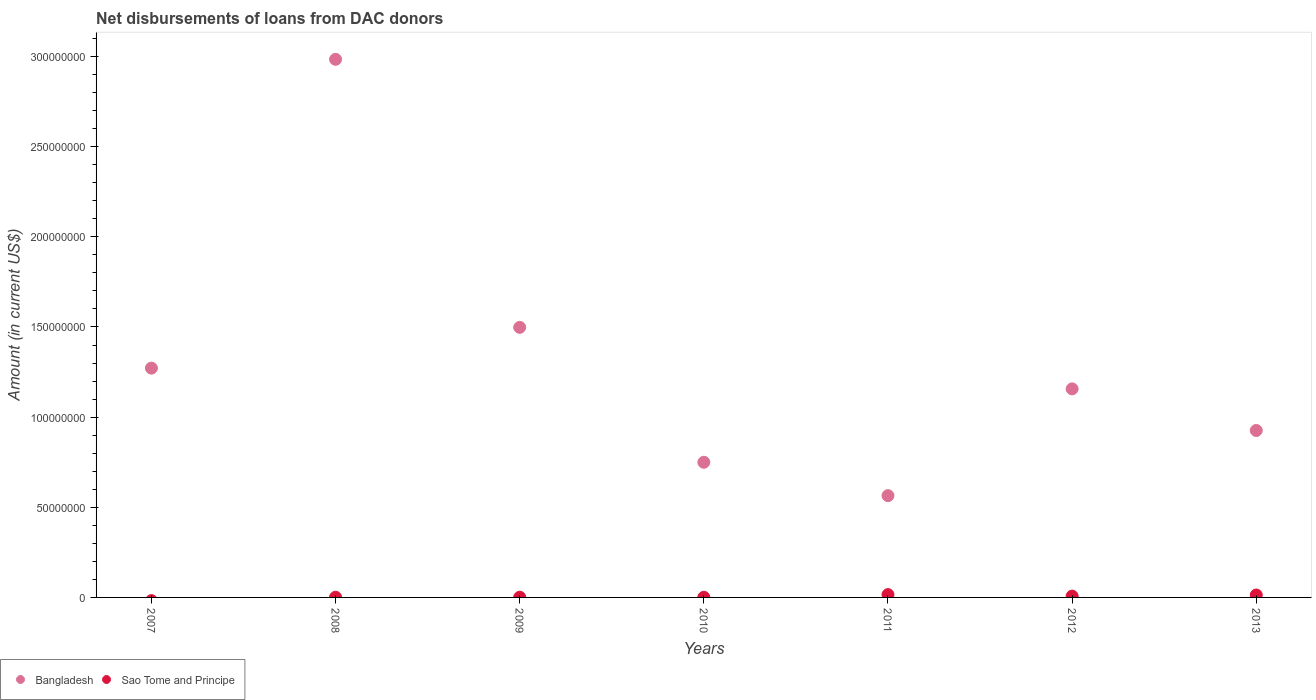Is the number of dotlines equal to the number of legend labels?
Your response must be concise. No. What is the amount of loans disbursed in Bangladesh in 2011?
Your answer should be very brief. 5.64e+07. Across all years, what is the maximum amount of loans disbursed in Sao Tome and Principe?
Provide a short and direct response. 1.56e+06. Across all years, what is the minimum amount of loans disbursed in Bangladesh?
Your answer should be compact. 5.64e+07. In which year was the amount of loans disbursed in Sao Tome and Principe maximum?
Ensure brevity in your answer.  2011. What is the total amount of loans disbursed in Sao Tome and Principe in the graph?
Provide a succinct answer. 3.98e+06. What is the difference between the amount of loans disbursed in Sao Tome and Principe in 2010 and that in 2011?
Your answer should be compact. -1.47e+06. What is the difference between the amount of loans disbursed in Sao Tome and Principe in 2011 and the amount of loans disbursed in Bangladesh in 2013?
Your answer should be very brief. -9.10e+07. What is the average amount of loans disbursed in Bangladesh per year?
Your answer should be very brief. 1.31e+08. In the year 2008, what is the difference between the amount of loans disbursed in Bangladesh and amount of loans disbursed in Sao Tome and Principe?
Provide a short and direct response. 2.98e+08. In how many years, is the amount of loans disbursed in Bangladesh greater than 120000000 US$?
Your response must be concise. 3. What is the ratio of the amount of loans disbursed in Sao Tome and Principe in 2008 to that in 2010?
Your answer should be very brief. 1.27. Is the difference between the amount of loans disbursed in Bangladesh in 2009 and 2013 greater than the difference between the amount of loans disbursed in Sao Tome and Principe in 2009 and 2013?
Keep it short and to the point. Yes. What is the difference between the highest and the second highest amount of loans disbursed in Sao Tome and Principe?
Provide a succinct answer. 2.13e+05. What is the difference between the highest and the lowest amount of loans disbursed in Bangladesh?
Your answer should be compact. 2.42e+08. How many dotlines are there?
Give a very brief answer. 2. How many years are there in the graph?
Provide a succinct answer. 7. Does the graph contain any zero values?
Your answer should be compact. Yes. Does the graph contain grids?
Your response must be concise. No. How are the legend labels stacked?
Give a very brief answer. Horizontal. What is the title of the graph?
Your answer should be very brief. Net disbursements of loans from DAC donors. What is the Amount (in current US$) of Bangladesh in 2007?
Your answer should be compact. 1.27e+08. What is the Amount (in current US$) of Bangladesh in 2008?
Offer a very short reply. 2.98e+08. What is the Amount (in current US$) of Sao Tome and Principe in 2008?
Your response must be concise. 1.18e+05. What is the Amount (in current US$) in Bangladesh in 2009?
Make the answer very short. 1.50e+08. What is the Amount (in current US$) of Sao Tome and Principe in 2009?
Your answer should be compact. 1.20e+05. What is the Amount (in current US$) of Bangladesh in 2010?
Provide a succinct answer. 7.50e+07. What is the Amount (in current US$) of Sao Tome and Principe in 2010?
Your response must be concise. 9.30e+04. What is the Amount (in current US$) in Bangladesh in 2011?
Your answer should be very brief. 5.64e+07. What is the Amount (in current US$) of Sao Tome and Principe in 2011?
Ensure brevity in your answer.  1.56e+06. What is the Amount (in current US$) of Bangladesh in 2012?
Your response must be concise. 1.16e+08. What is the Amount (in current US$) of Sao Tome and Principe in 2012?
Offer a terse response. 7.36e+05. What is the Amount (in current US$) of Bangladesh in 2013?
Ensure brevity in your answer.  9.26e+07. What is the Amount (in current US$) of Sao Tome and Principe in 2013?
Keep it short and to the point. 1.35e+06. Across all years, what is the maximum Amount (in current US$) of Bangladesh?
Provide a succinct answer. 2.98e+08. Across all years, what is the maximum Amount (in current US$) of Sao Tome and Principe?
Offer a terse response. 1.56e+06. Across all years, what is the minimum Amount (in current US$) of Bangladesh?
Your response must be concise. 5.64e+07. Across all years, what is the minimum Amount (in current US$) in Sao Tome and Principe?
Provide a succinct answer. 0. What is the total Amount (in current US$) of Bangladesh in the graph?
Give a very brief answer. 9.15e+08. What is the total Amount (in current US$) in Sao Tome and Principe in the graph?
Provide a succinct answer. 3.98e+06. What is the difference between the Amount (in current US$) in Bangladesh in 2007 and that in 2008?
Your response must be concise. -1.71e+08. What is the difference between the Amount (in current US$) in Bangladesh in 2007 and that in 2009?
Provide a succinct answer. -2.26e+07. What is the difference between the Amount (in current US$) of Bangladesh in 2007 and that in 2010?
Your response must be concise. 5.22e+07. What is the difference between the Amount (in current US$) of Bangladesh in 2007 and that in 2011?
Make the answer very short. 7.07e+07. What is the difference between the Amount (in current US$) in Bangladesh in 2007 and that in 2012?
Offer a very short reply. 1.15e+07. What is the difference between the Amount (in current US$) in Bangladesh in 2007 and that in 2013?
Provide a short and direct response. 3.46e+07. What is the difference between the Amount (in current US$) in Bangladesh in 2008 and that in 2009?
Provide a succinct answer. 1.49e+08. What is the difference between the Amount (in current US$) of Sao Tome and Principe in 2008 and that in 2009?
Your answer should be compact. -2000. What is the difference between the Amount (in current US$) of Bangladesh in 2008 and that in 2010?
Keep it short and to the point. 2.24e+08. What is the difference between the Amount (in current US$) in Sao Tome and Principe in 2008 and that in 2010?
Offer a very short reply. 2.50e+04. What is the difference between the Amount (in current US$) of Bangladesh in 2008 and that in 2011?
Your answer should be very brief. 2.42e+08. What is the difference between the Amount (in current US$) of Sao Tome and Principe in 2008 and that in 2011?
Your answer should be compact. -1.44e+06. What is the difference between the Amount (in current US$) in Bangladesh in 2008 and that in 2012?
Provide a succinct answer. 1.83e+08. What is the difference between the Amount (in current US$) in Sao Tome and Principe in 2008 and that in 2012?
Make the answer very short. -6.18e+05. What is the difference between the Amount (in current US$) in Bangladesh in 2008 and that in 2013?
Provide a succinct answer. 2.06e+08. What is the difference between the Amount (in current US$) of Sao Tome and Principe in 2008 and that in 2013?
Provide a short and direct response. -1.23e+06. What is the difference between the Amount (in current US$) of Bangladesh in 2009 and that in 2010?
Offer a terse response. 7.48e+07. What is the difference between the Amount (in current US$) in Sao Tome and Principe in 2009 and that in 2010?
Provide a short and direct response. 2.70e+04. What is the difference between the Amount (in current US$) of Bangladesh in 2009 and that in 2011?
Ensure brevity in your answer.  9.33e+07. What is the difference between the Amount (in current US$) in Sao Tome and Principe in 2009 and that in 2011?
Your answer should be very brief. -1.44e+06. What is the difference between the Amount (in current US$) in Bangladesh in 2009 and that in 2012?
Keep it short and to the point. 3.41e+07. What is the difference between the Amount (in current US$) in Sao Tome and Principe in 2009 and that in 2012?
Your answer should be compact. -6.16e+05. What is the difference between the Amount (in current US$) of Bangladesh in 2009 and that in 2013?
Give a very brief answer. 5.72e+07. What is the difference between the Amount (in current US$) in Sao Tome and Principe in 2009 and that in 2013?
Offer a very short reply. -1.23e+06. What is the difference between the Amount (in current US$) in Bangladesh in 2010 and that in 2011?
Offer a terse response. 1.85e+07. What is the difference between the Amount (in current US$) of Sao Tome and Principe in 2010 and that in 2011?
Your answer should be very brief. -1.47e+06. What is the difference between the Amount (in current US$) in Bangladesh in 2010 and that in 2012?
Keep it short and to the point. -4.07e+07. What is the difference between the Amount (in current US$) of Sao Tome and Principe in 2010 and that in 2012?
Keep it short and to the point. -6.43e+05. What is the difference between the Amount (in current US$) of Bangladesh in 2010 and that in 2013?
Provide a succinct answer. -1.76e+07. What is the difference between the Amount (in current US$) of Sao Tome and Principe in 2010 and that in 2013?
Offer a terse response. -1.26e+06. What is the difference between the Amount (in current US$) in Bangladesh in 2011 and that in 2012?
Provide a short and direct response. -5.92e+07. What is the difference between the Amount (in current US$) of Sao Tome and Principe in 2011 and that in 2012?
Provide a short and direct response. 8.27e+05. What is the difference between the Amount (in current US$) in Bangladesh in 2011 and that in 2013?
Provide a succinct answer. -3.61e+07. What is the difference between the Amount (in current US$) in Sao Tome and Principe in 2011 and that in 2013?
Keep it short and to the point. 2.13e+05. What is the difference between the Amount (in current US$) of Bangladesh in 2012 and that in 2013?
Your answer should be compact. 2.31e+07. What is the difference between the Amount (in current US$) in Sao Tome and Principe in 2012 and that in 2013?
Make the answer very short. -6.14e+05. What is the difference between the Amount (in current US$) of Bangladesh in 2007 and the Amount (in current US$) of Sao Tome and Principe in 2008?
Keep it short and to the point. 1.27e+08. What is the difference between the Amount (in current US$) of Bangladesh in 2007 and the Amount (in current US$) of Sao Tome and Principe in 2009?
Offer a terse response. 1.27e+08. What is the difference between the Amount (in current US$) of Bangladesh in 2007 and the Amount (in current US$) of Sao Tome and Principe in 2010?
Provide a short and direct response. 1.27e+08. What is the difference between the Amount (in current US$) of Bangladesh in 2007 and the Amount (in current US$) of Sao Tome and Principe in 2011?
Ensure brevity in your answer.  1.26e+08. What is the difference between the Amount (in current US$) in Bangladesh in 2007 and the Amount (in current US$) in Sao Tome and Principe in 2012?
Offer a very short reply. 1.26e+08. What is the difference between the Amount (in current US$) in Bangladesh in 2007 and the Amount (in current US$) in Sao Tome and Principe in 2013?
Provide a succinct answer. 1.26e+08. What is the difference between the Amount (in current US$) of Bangladesh in 2008 and the Amount (in current US$) of Sao Tome and Principe in 2009?
Offer a terse response. 2.98e+08. What is the difference between the Amount (in current US$) of Bangladesh in 2008 and the Amount (in current US$) of Sao Tome and Principe in 2010?
Give a very brief answer. 2.98e+08. What is the difference between the Amount (in current US$) of Bangladesh in 2008 and the Amount (in current US$) of Sao Tome and Principe in 2011?
Make the answer very short. 2.97e+08. What is the difference between the Amount (in current US$) in Bangladesh in 2008 and the Amount (in current US$) in Sao Tome and Principe in 2012?
Offer a very short reply. 2.98e+08. What is the difference between the Amount (in current US$) in Bangladesh in 2008 and the Amount (in current US$) in Sao Tome and Principe in 2013?
Your answer should be compact. 2.97e+08. What is the difference between the Amount (in current US$) of Bangladesh in 2009 and the Amount (in current US$) of Sao Tome and Principe in 2010?
Ensure brevity in your answer.  1.50e+08. What is the difference between the Amount (in current US$) of Bangladesh in 2009 and the Amount (in current US$) of Sao Tome and Principe in 2011?
Your response must be concise. 1.48e+08. What is the difference between the Amount (in current US$) in Bangladesh in 2009 and the Amount (in current US$) in Sao Tome and Principe in 2012?
Offer a terse response. 1.49e+08. What is the difference between the Amount (in current US$) of Bangladesh in 2009 and the Amount (in current US$) of Sao Tome and Principe in 2013?
Give a very brief answer. 1.48e+08. What is the difference between the Amount (in current US$) of Bangladesh in 2010 and the Amount (in current US$) of Sao Tome and Principe in 2011?
Your response must be concise. 7.34e+07. What is the difference between the Amount (in current US$) of Bangladesh in 2010 and the Amount (in current US$) of Sao Tome and Principe in 2012?
Provide a succinct answer. 7.42e+07. What is the difference between the Amount (in current US$) of Bangladesh in 2010 and the Amount (in current US$) of Sao Tome and Principe in 2013?
Your response must be concise. 7.36e+07. What is the difference between the Amount (in current US$) in Bangladesh in 2011 and the Amount (in current US$) in Sao Tome and Principe in 2012?
Give a very brief answer. 5.57e+07. What is the difference between the Amount (in current US$) in Bangladesh in 2011 and the Amount (in current US$) in Sao Tome and Principe in 2013?
Your answer should be very brief. 5.51e+07. What is the difference between the Amount (in current US$) in Bangladesh in 2012 and the Amount (in current US$) in Sao Tome and Principe in 2013?
Ensure brevity in your answer.  1.14e+08. What is the average Amount (in current US$) of Bangladesh per year?
Ensure brevity in your answer.  1.31e+08. What is the average Amount (in current US$) in Sao Tome and Principe per year?
Ensure brevity in your answer.  5.69e+05. In the year 2008, what is the difference between the Amount (in current US$) of Bangladesh and Amount (in current US$) of Sao Tome and Principe?
Offer a terse response. 2.98e+08. In the year 2009, what is the difference between the Amount (in current US$) in Bangladesh and Amount (in current US$) in Sao Tome and Principe?
Keep it short and to the point. 1.50e+08. In the year 2010, what is the difference between the Amount (in current US$) in Bangladesh and Amount (in current US$) in Sao Tome and Principe?
Your answer should be very brief. 7.49e+07. In the year 2011, what is the difference between the Amount (in current US$) in Bangladesh and Amount (in current US$) in Sao Tome and Principe?
Provide a succinct answer. 5.49e+07. In the year 2012, what is the difference between the Amount (in current US$) of Bangladesh and Amount (in current US$) of Sao Tome and Principe?
Provide a short and direct response. 1.15e+08. In the year 2013, what is the difference between the Amount (in current US$) of Bangladesh and Amount (in current US$) of Sao Tome and Principe?
Give a very brief answer. 9.12e+07. What is the ratio of the Amount (in current US$) of Bangladesh in 2007 to that in 2008?
Offer a very short reply. 0.43. What is the ratio of the Amount (in current US$) in Bangladesh in 2007 to that in 2009?
Your response must be concise. 0.85. What is the ratio of the Amount (in current US$) in Bangladesh in 2007 to that in 2010?
Offer a very short reply. 1.7. What is the ratio of the Amount (in current US$) of Bangladesh in 2007 to that in 2011?
Your response must be concise. 2.25. What is the ratio of the Amount (in current US$) of Bangladesh in 2007 to that in 2012?
Make the answer very short. 1.1. What is the ratio of the Amount (in current US$) of Bangladesh in 2007 to that in 2013?
Keep it short and to the point. 1.37. What is the ratio of the Amount (in current US$) in Bangladesh in 2008 to that in 2009?
Offer a very short reply. 1.99. What is the ratio of the Amount (in current US$) in Sao Tome and Principe in 2008 to that in 2009?
Your response must be concise. 0.98. What is the ratio of the Amount (in current US$) of Bangladesh in 2008 to that in 2010?
Give a very brief answer. 3.98. What is the ratio of the Amount (in current US$) in Sao Tome and Principe in 2008 to that in 2010?
Offer a very short reply. 1.27. What is the ratio of the Amount (in current US$) in Bangladesh in 2008 to that in 2011?
Give a very brief answer. 5.29. What is the ratio of the Amount (in current US$) in Sao Tome and Principe in 2008 to that in 2011?
Provide a succinct answer. 0.08. What is the ratio of the Amount (in current US$) in Bangladesh in 2008 to that in 2012?
Your answer should be compact. 2.58. What is the ratio of the Amount (in current US$) of Sao Tome and Principe in 2008 to that in 2012?
Ensure brevity in your answer.  0.16. What is the ratio of the Amount (in current US$) of Bangladesh in 2008 to that in 2013?
Offer a terse response. 3.22. What is the ratio of the Amount (in current US$) in Sao Tome and Principe in 2008 to that in 2013?
Offer a very short reply. 0.09. What is the ratio of the Amount (in current US$) of Bangladesh in 2009 to that in 2010?
Provide a succinct answer. 2. What is the ratio of the Amount (in current US$) in Sao Tome and Principe in 2009 to that in 2010?
Give a very brief answer. 1.29. What is the ratio of the Amount (in current US$) of Bangladesh in 2009 to that in 2011?
Keep it short and to the point. 2.65. What is the ratio of the Amount (in current US$) in Sao Tome and Principe in 2009 to that in 2011?
Offer a terse response. 0.08. What is the ratio of the Amount (in current US$) of Bangladesh in 2009 to that in 2012?
Give a very brief answer. 1.29. What is the ratio of the Amount (in current US$) of Sao Tome and Principe in 2009 to that in 2012?
Ensure brevity in your answer.  0.16. What is the ratio of the Amount (in current US$) of Bangladesh in 2009 to that in 2013?
Provide a short and direct response. 1.62. What is the ratio of the Amount (in current US$) of Sao Tome and Principe in 2009 to that in 2013?
Your response must be concise. 0.09. What is the ratio of the Amount (in current US$) of Bangladesh in 2010 to that in 2011?
Provide a short and direct response. 1.33. What is the ratio of the Amount (in current US$) of Sao Tome and Principe in 2010 to that in 2011?
Provide a succinct answer. 0.06. What is the ratio of the Amount (in current US$) of Bangladesh in 2010 to that in 2012?
Offer a very short reply. 0.65. What is the ratio of the Amount (in current US$) of Sao Tome and Principe in 2010 to that in 2012?
Give a very brief answer. 0.13. What is the ratio of the Amount (in current US$) of Bangladesh in 2010 to that in 2013?
Your response must be concise. 0.81. What is the ratio of the Amount (in current US$) of Sao Tome and Principe in 2010 to that in 2013?
Make the answer very short. 0.07. What is the ratio of the Amount (in current US$) in Bangladesh in 2011 to that in 2012?
Provide a short and direct response. 0.49. What is the ratio of the Amount (in current US$) in Sao Tome and Principe in 2011 to that in 2012?
Offer a terse response. 2.12. What is the ratio of the Amount (in current US$) in Bangladesh in 2011 to that in 2013?
Offer a very short reply. 0.61. What is the ratio of the Amount (in current US$) of Sao Tome and Principe in 2011 to that in 2013?
Keep it short and to the point. 1.16. What is the ratio of the Amount (in current US$) in Bangladesh in 2012 to that in 2013?
Provide a succinct answer. 1.25. What is the ratio of the Amount (in current US$) of Sao Tome and Principe in 2012 to that in 2013?
Ensure brevity in your answer.  0.55. What is the difference between the highest and the second highest Amount (in current US$) in Bangladesh?
Give a very brief answer. 1.49e+08. What is the difference between the highest and the second highest Amount (in current US$) of Sao Tome and Principe?
Your response must be concise. 2.13e+05. What is the difference between the highest and the lowest Amount (in current US$) in Bangladesh?
Ensure brevity in your answer.  2.42e+08. What is the difference between the highest and the lowest Amount (in current US$) in Sao Tome and Principe?
Offer a very short reply. 1.56e+06. 